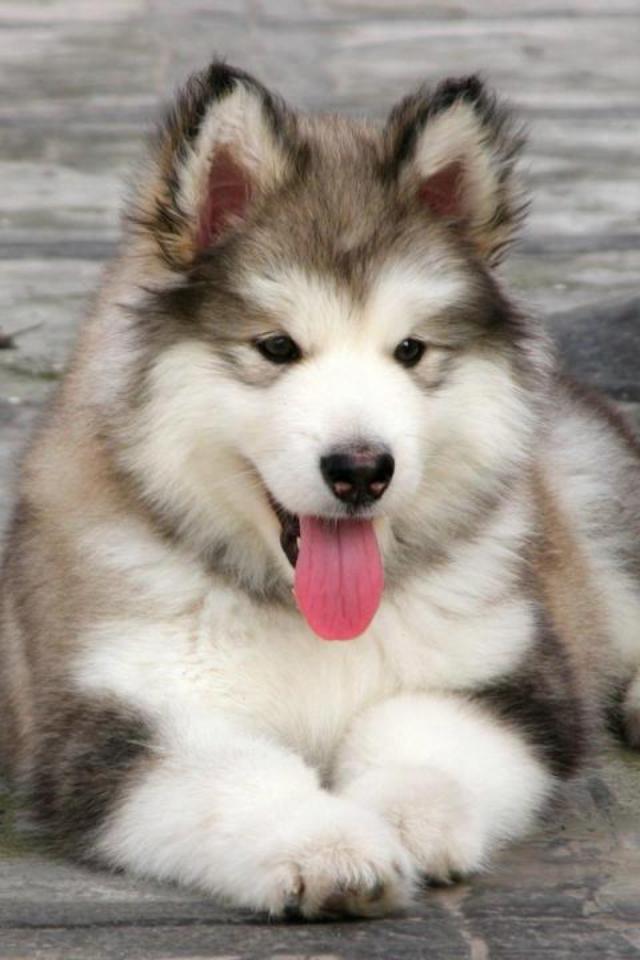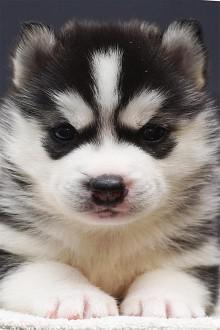The first image is the image on the left, the second image is the image on the right. Assess this claim about the two images: "One of the two malamutes has its tongue sticking out, while the other is just staring at the camera.". Correct or not? Answer yes or no. Yes. The first image is the image on the left, the second image is the image on the right. For the images shown, is this caption "The puppy on the left has its tongue visible." true? Answer yes or no. Yes. 